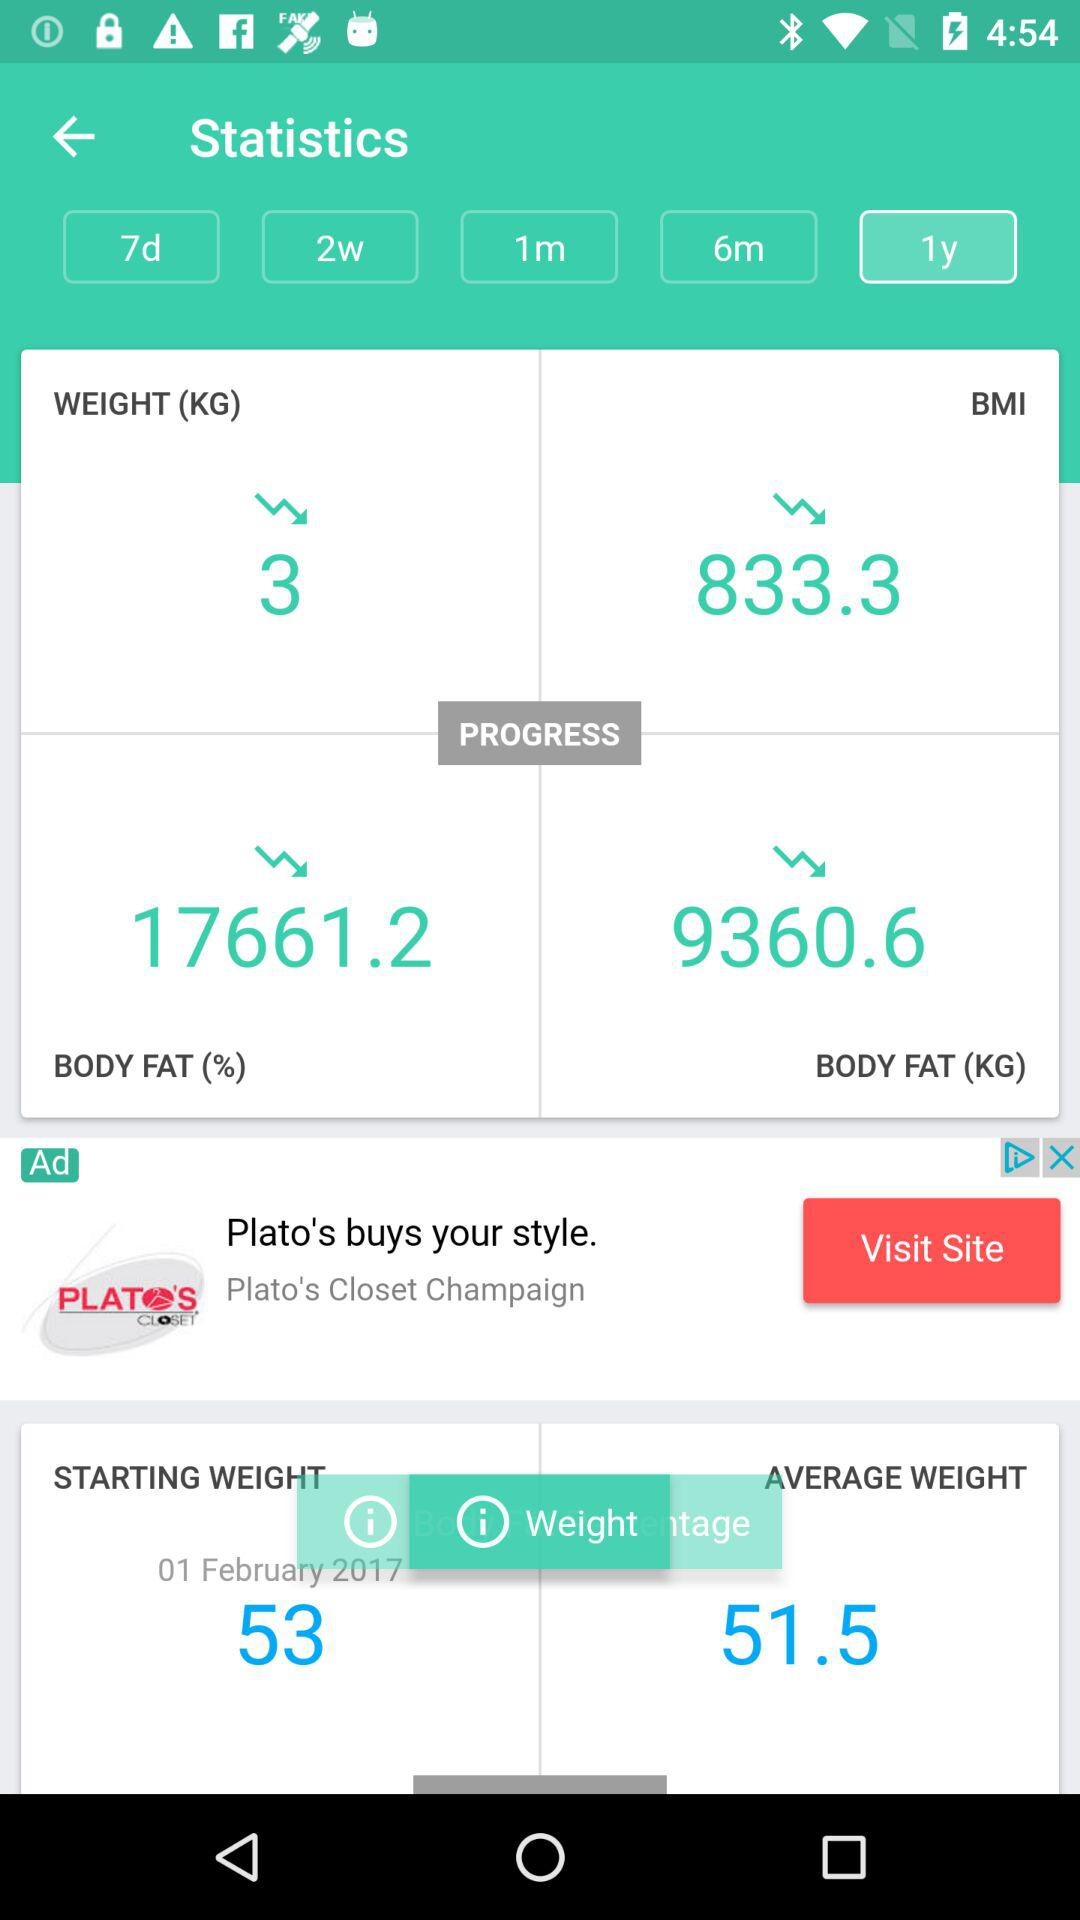What is the BMI of the user?
Answer the question using a single word or phrase. 833.3 